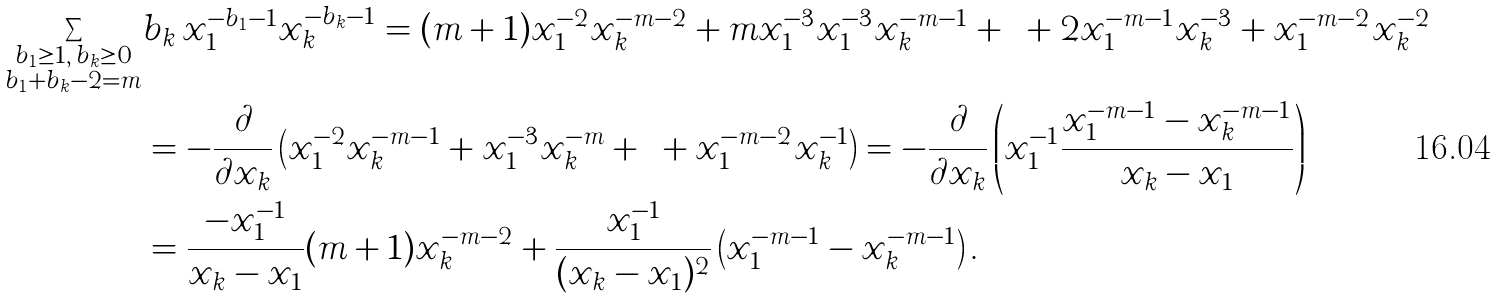Convert formula to latex. <formula><loc_0><loc_0><loc_500><loc_500>\sum _ { \substack { b _ { 1 } \geq 1 , \, b _ { k } \geq 0 \\ b _ { 1 } + b _ { k } - 2 = m } } & b _ { k } \, x _ { 1 } ^ { - b _ { 1 } - 1 } x _ { k } ^ { - b _ { k } - 1 } = ( m + 1 ) x _ { 1 } ^ { - 2 } x _ { k } ^ { - m - 2 } + m x _ { 1 } ^ { - 3 } x _ { 1 } ^ { - 3 } x _ { k } ^ { - m - 1 } + \cdots + 2 x _ { 1 } ^ { - m - 1 } x _ { k } ^ { - 3 } + x _ { 1 } ^ { - m - 2 } x _ { k } ^ { - 2 } \\ & = - \frac { \partial } { \partial x _ { k } } \left ( x _ { 1 } ^ { - 2 } x _ { k } ^ { - m - 1 } + x _ { 1 } ^ { - 3 } x _ { k } ^ { - m } + \cdots + x _ { 1 } ^ { - m - 2 } x _ { k } ^ { - 1 } \right ) = - \frac { \partial } { \partial x _ { k } } \left ( x _ { 1 } ^ { - 1 } \frac { x _ { 1 } ^ { - m - 1 } - x _ { k } ^ { - m - 1 } } { x _ { k } - x _ { 1 } } \right ) \\ & = \frac { - x _ { 1 } ^ { - 1 } } { x _ { k } - x _ { 1 } } ( m + 1 ) x _ { k } ^ { - m - 2 } + \frac { x _ { 1 } ^ { - 1 } } { ( x _ { k } - x _ { 1 } ) ^ { 2 } } \left ( x _ { 1 } ^ { - m - 1 } - x _ { k } ^ { - m - 1 } \right ) .</formula> 